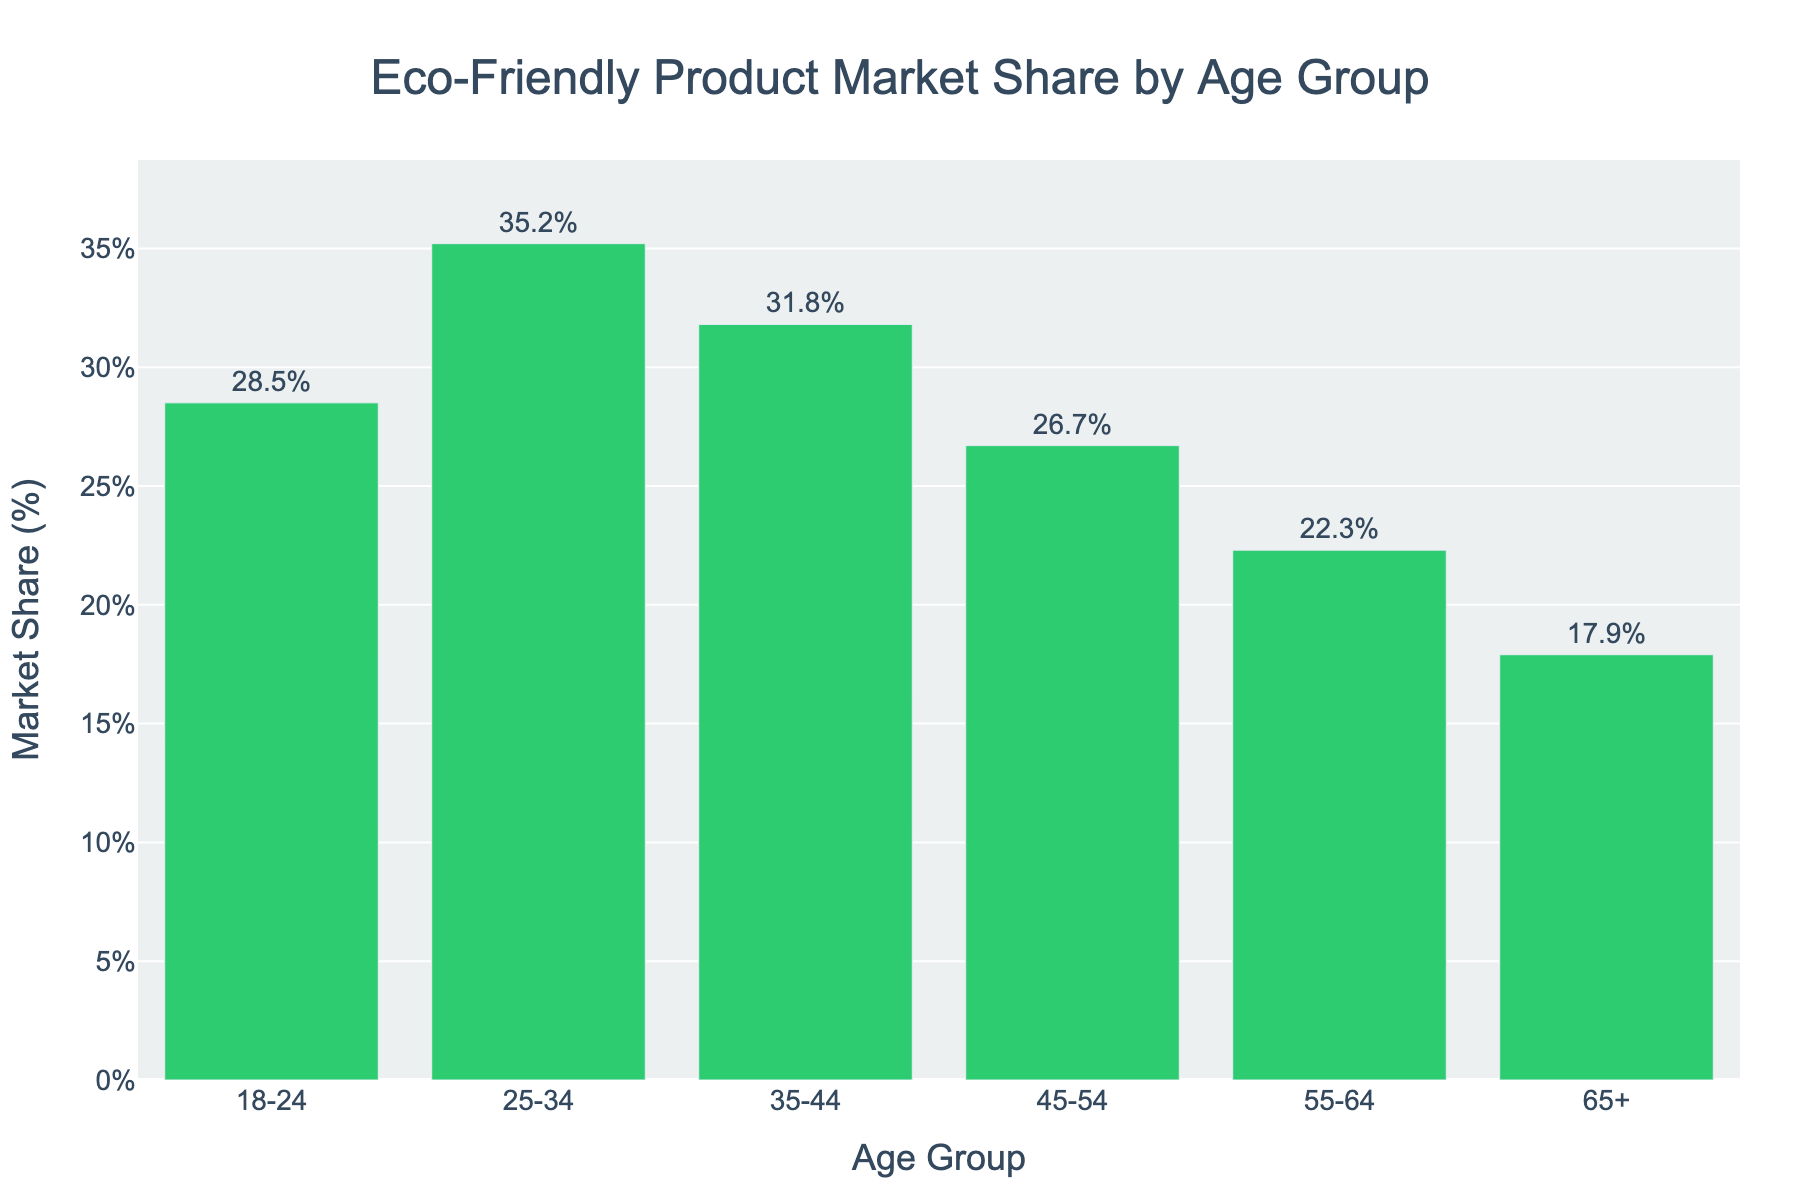What age group has the highest market share for eco-friendly products? The age group with the highest market share has the tallest bar in the plot. The 25-34 age group has the tallest bar.
Answer: 25-34 Which age group has the lowest market share for eco-friendly products? The group with the shortest bar represents the lowest market share. The 65+ age group has the shortest bar.
Answer: 65+ What's the difference in market share between the 18-24 and 45-54 age groups? The difference is calculated by subtracting the market share of the 45-54 age group from the 18-24 age group. The values are 28.5% and 26.7%, respectively. 28.5 - 26.7 = 1.8%
Answer: 1.8% What is the total market share for the 35-44, 45-54, and 55-64 age groups combined? The total market share is found by adding the percentages for these age groups. 31.8% + 26.7% + 22.3% = 80.8%
Answer: 80.8% Which age groups have a market share greater than 30%? The age groups with a market share above 30% have bars that exceed the 30% mark on the y-axis. The 18-24 (28.5%), 25-34 (35.2%), and 35-44 (31.8%) age groups qualify. Only 25-34 and 35-44 exceed 30%.
Answer: 25-34, 35-44 What’s the average market share of all the age groups? The average market share is the sum of all percentages divided by the number of age groups. Sum = 28.5 + 35.2 + 31.8 + 26.7 + 22.3 + 17.9 = 162.4. Average: 162.4 / 6 ≈ 27.1%
Answer: 27.1% How much higher is the market share of the 25-34 age group compared to the 55-64 age group? The difference is calculated by subtracting the market share of the 55-64 age group from the 25-34 age group. 35.2% - 22.3% = 12.9%
Answer: 12.9% Which age group has a market share closest to 20%? By examining the y-values, the age group with the market share closest to 20% is identified. The 55-64 age group has a percentage of 22.3%, making it the closest.
Answer: 55-64 What is the sum of the market share for the age groups below 35 years? Add the market shares of 18-24 and 25-34 age groups. 28.5% + 35.2% = 63.7%
Answer: 63.7% Which age group shows a market share nearest to the overall average market share? First, calculate the average market share as 27.1%. Compare each age group's share to the average and find the nearest. The 18-24 age group has 28.5%, which is closest to 27.1%.
Answer: 18-24 